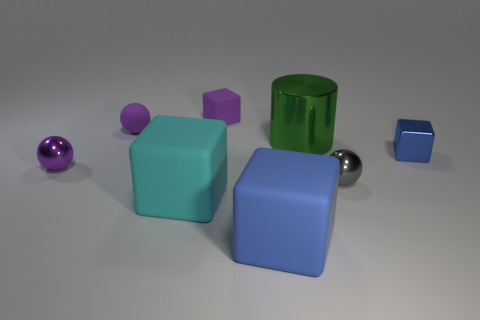Subtract 1 cubes. How many cubes are left? 3 Add 1 cyan matte things. How many objects exist? 9 Subtract all cylinders. How many objects are left? 7 Add 4 blue objects. How many blue objects exist? 6 Subtract 0 blue cylinders. How many objects are left? 8 Subtract all large yellow spheres. Subtract all big cylinders. How many objects are left? 7 Add 2 green shiny cylinders. How many green shiny cylinders are left? 3 